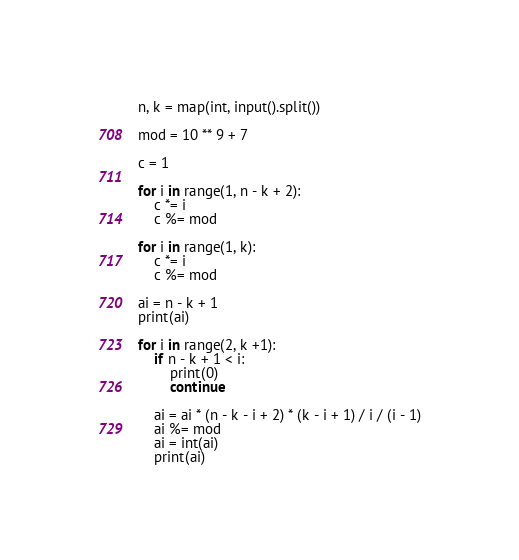Convert code to text. <code><loc_0><loc_0><loc_500><loc_500><_Python_>n, k = map(int, input().split())

mod = 10 ** 9 + 7

c = 1

for i in range(1, n - k + 2):
    c *= i
    c %= mod

for i in range(1, k):
    c *= i
    c %= mod

ai = n - k + 1
print(ai)

for i in range(2, k +1):
    if n - k + 1 < i:
        print(0)
        continue

    ai = ai * (n - k - i + 2) * (k - i + 1) / i / (i - 1)
    ai %= mod
    ai = int(ai)
    print(ai)
</code> 